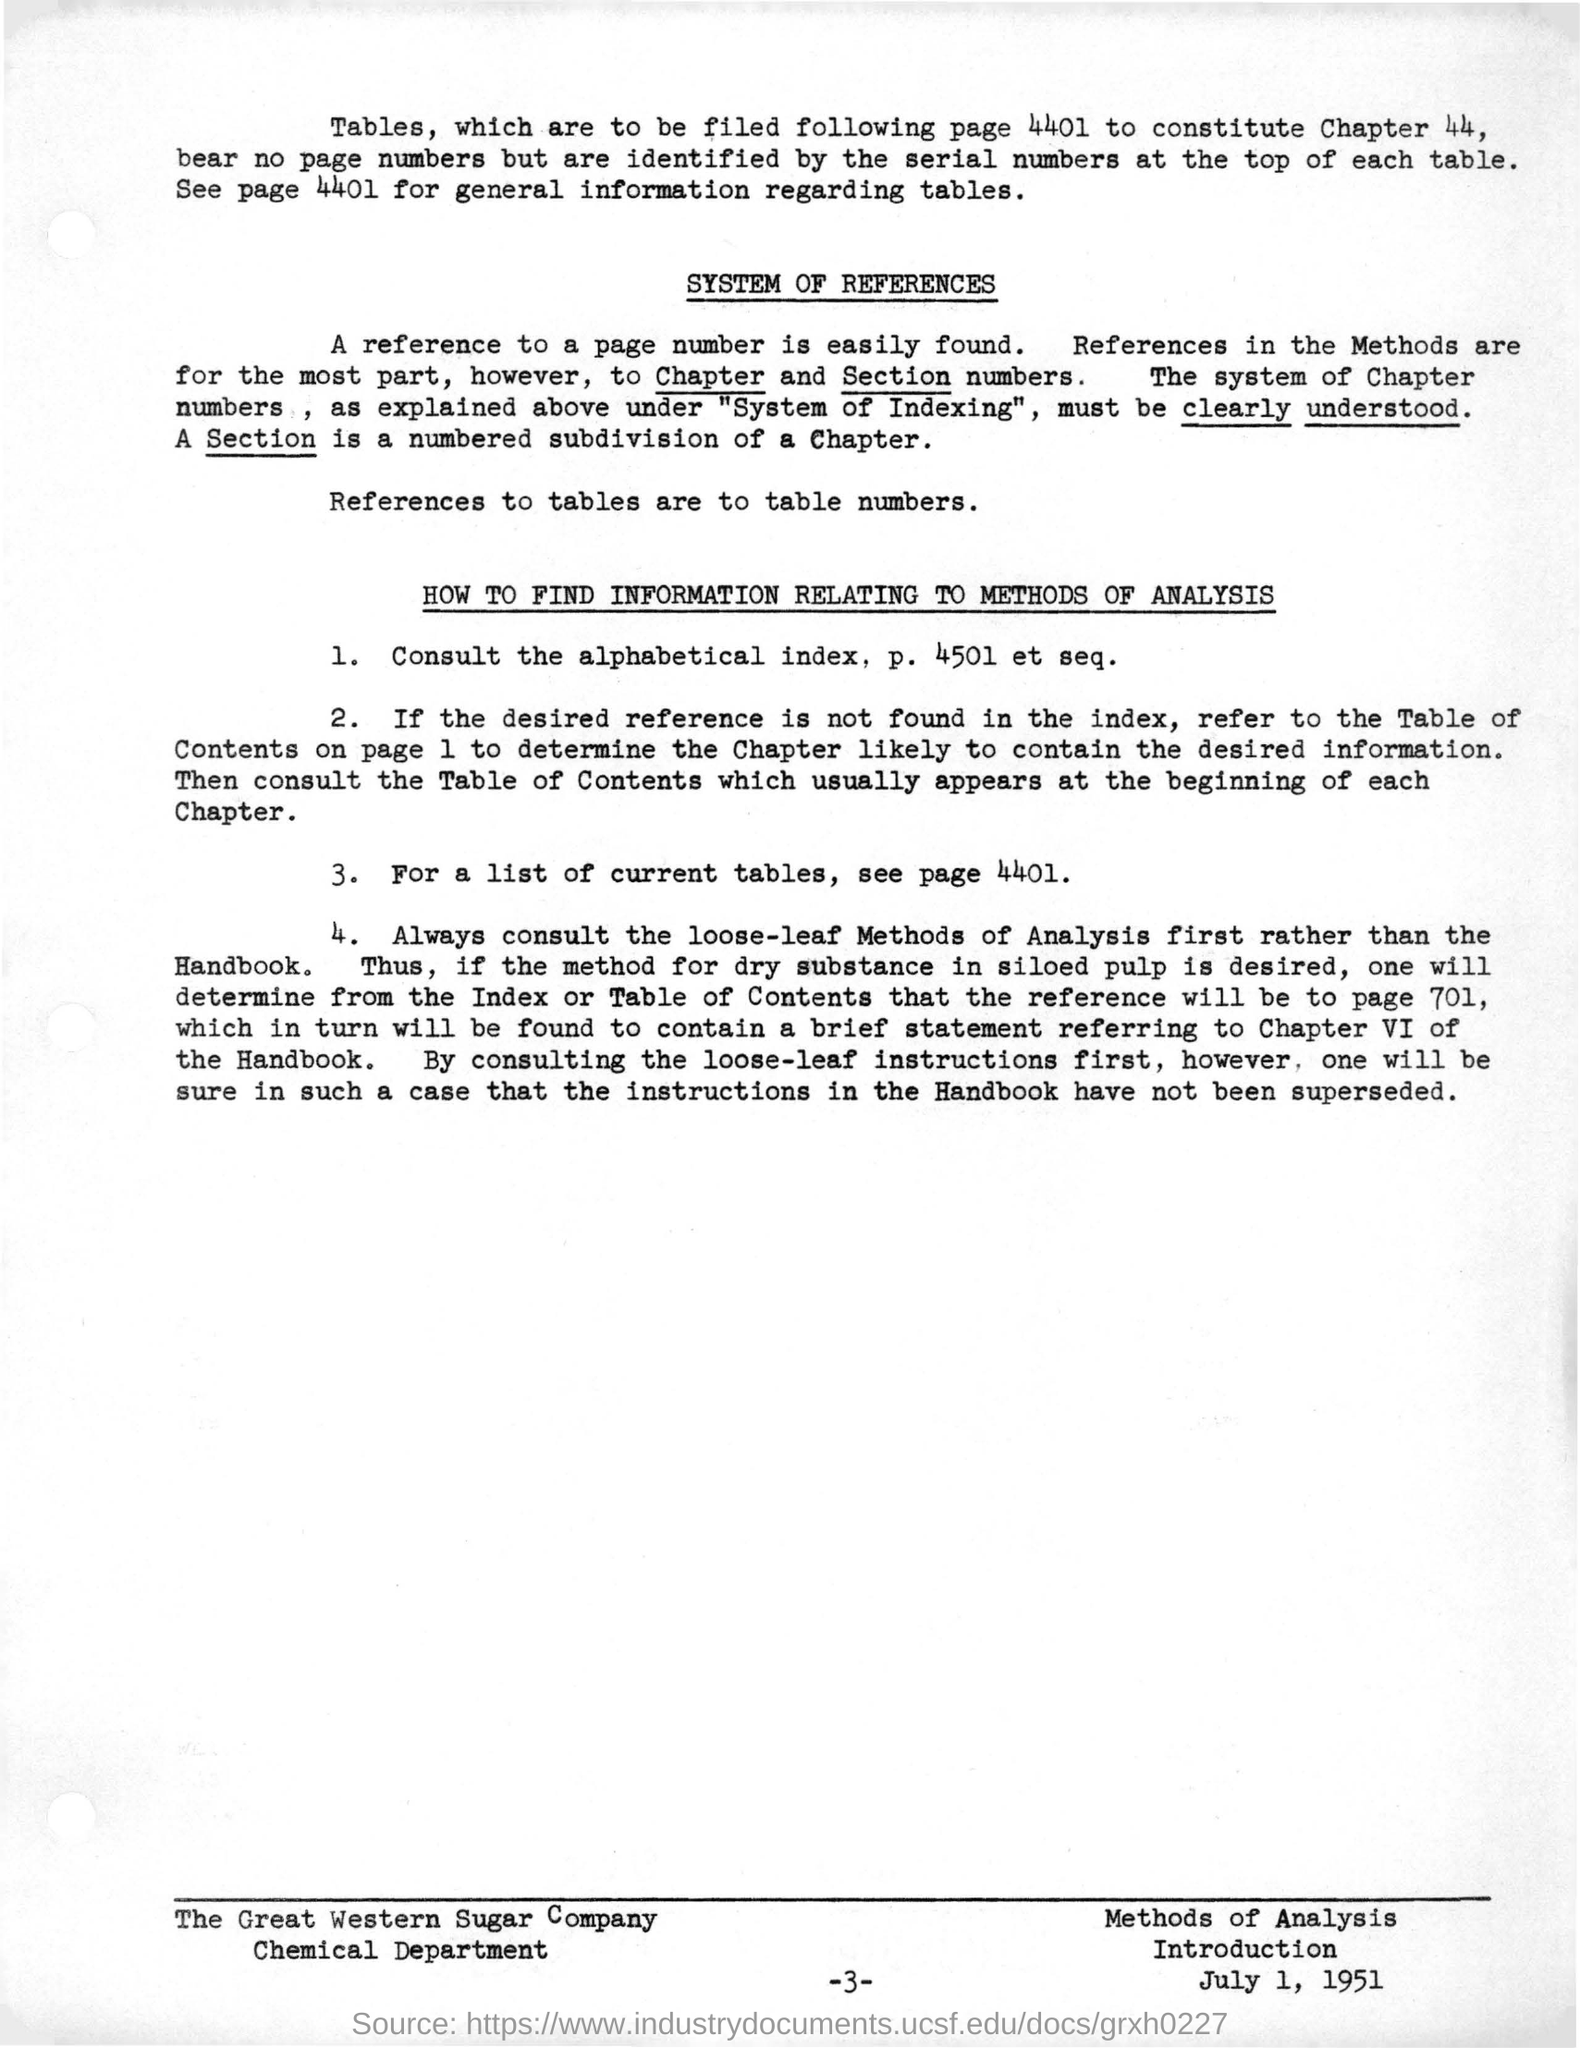Identify some key points in this picture. I am seeking information on a webpage that provides a list of current tables. It is advisable to consult other sources, such as the loose-leaf, rather than the handbook, when seeking answers to legal questions. It is possible to reference easily found information by using a page number. The information regarding tables can be found on page 4401, and a list of current tables can be found on page 4401 as well. 